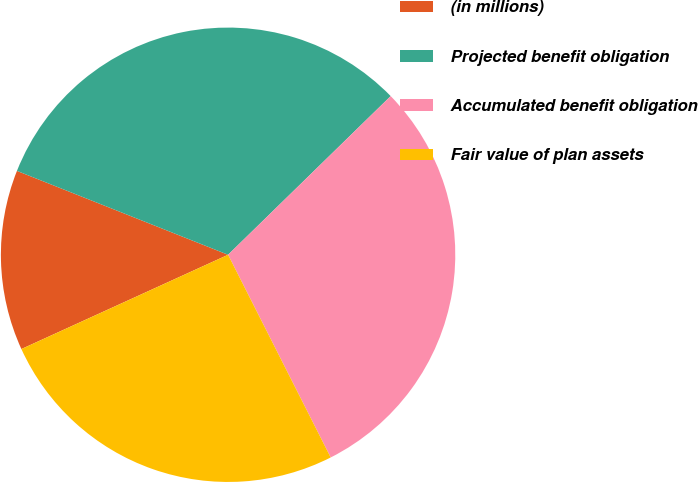Convert chart. <chart><loc_0><loc_0><loc_500><loc_500><pie_chart><fcel>(in millions)<fcel>Projected benefit obligation<fcel>Accumulated benefit obligation<fcel>Fair value of plan assets<nl><fcel>12.83%<fcel>31.68%<fcel>29.85%<fcel>25.65%<nl></chart> 